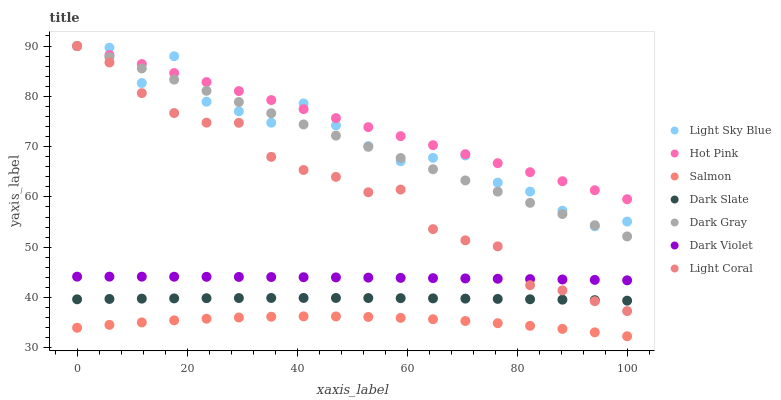Does Salmon have the minimum area under the curve?
Answer yes or no. Yes. Does Hot Pink have the maximum area under the curve?
Answer yes or no. Yes. Does Hot Pink have the minimum area under the curve?
Answer yes or no. No. Does Salmon have the maximum area under the curve?
Answer yes or no. No. Is Dark Gray the smoothest?
Answer yes or no. Yes. Is Light Sky Blue the roughest?
Answer yes or no. Yes. Is Hot Pink the smoothest?
Answer yes or no. No. Is Hot Pink the roughest?
Answer yes or no. No. Does Salmon have the lowest value?
Answer yes or no. Yes. Does Hot Pink have the lowest value?
Answer yes or no. No. Does Light Sky Blue have the highest value?
Answer yes or no. Yes. Does Salmon have the highest value?
Answer yes or no. No. Is Salmon less than Dark Gray?
Answer yes or no. Yes. Is Dark Gray greater than Dark Violet?
Answer yes or no. Yes. Does Light Coral intersect Dark Gray?
Answer yes or no. Yes. Is Light Coral less than Dark Gray?
Answer yes or no. No. Is Light Coral greater than Dark Gray?
Answer yes or no. No. Does Salmon intersect Dark Gray?
Answer yes or no. No. 